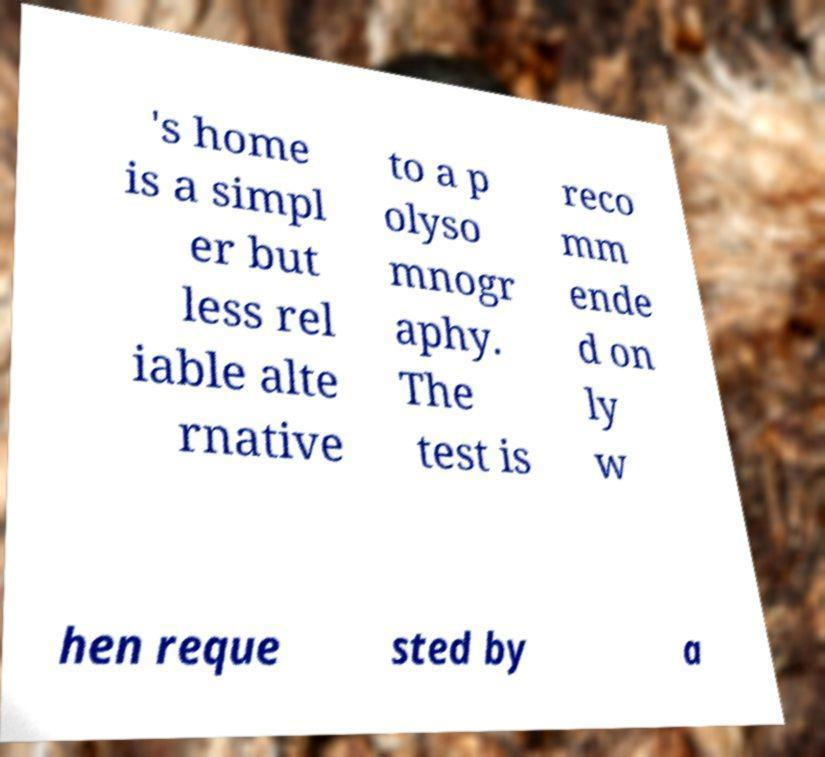What messages or text are displayed in this image? I need them in a readable, typed format. 's home is a simpl er but less rel iable alte rnative to a p olyso mnogr aphy. The test is reco mm ende d on ly w hen reque sted by a 